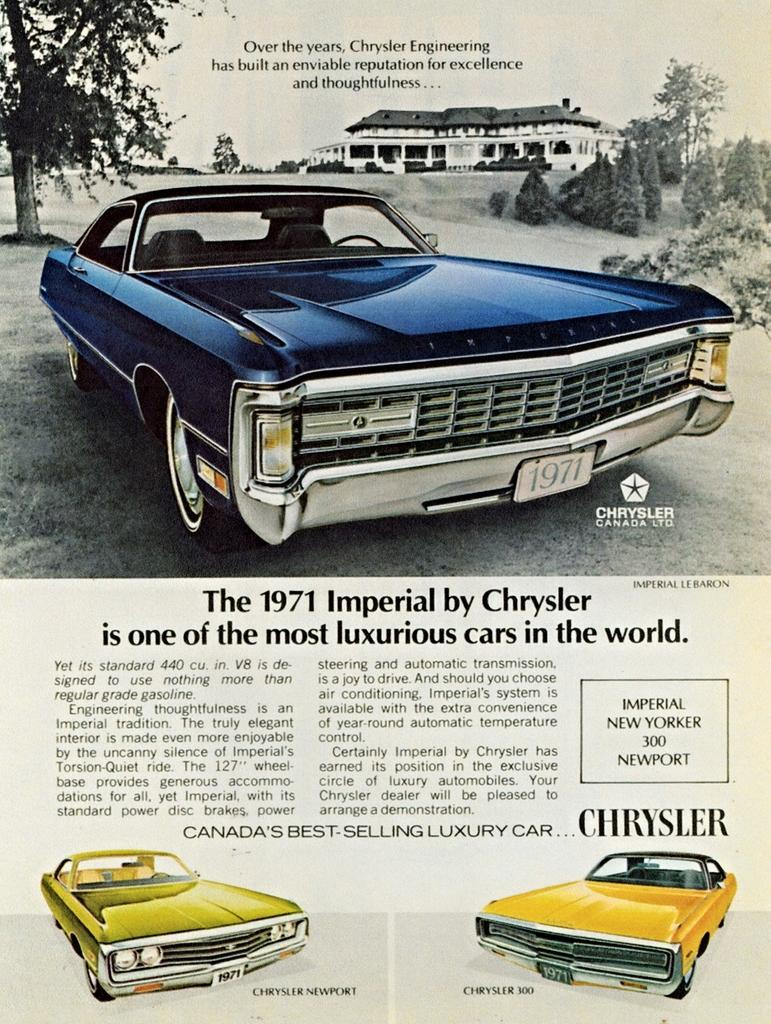What is present on the paper in the image? There is text on the paper in the image. What else can be seen in the image besides the paper? There are cars in the image. Can you describe the text on the paper? Unfortunately, the specific content of the text cannot be determined from the image. How many deer can be seen in the image? There are no deer present in the image. What color is the wristband on the person in the image? There is no person or wristband visible in the image. 